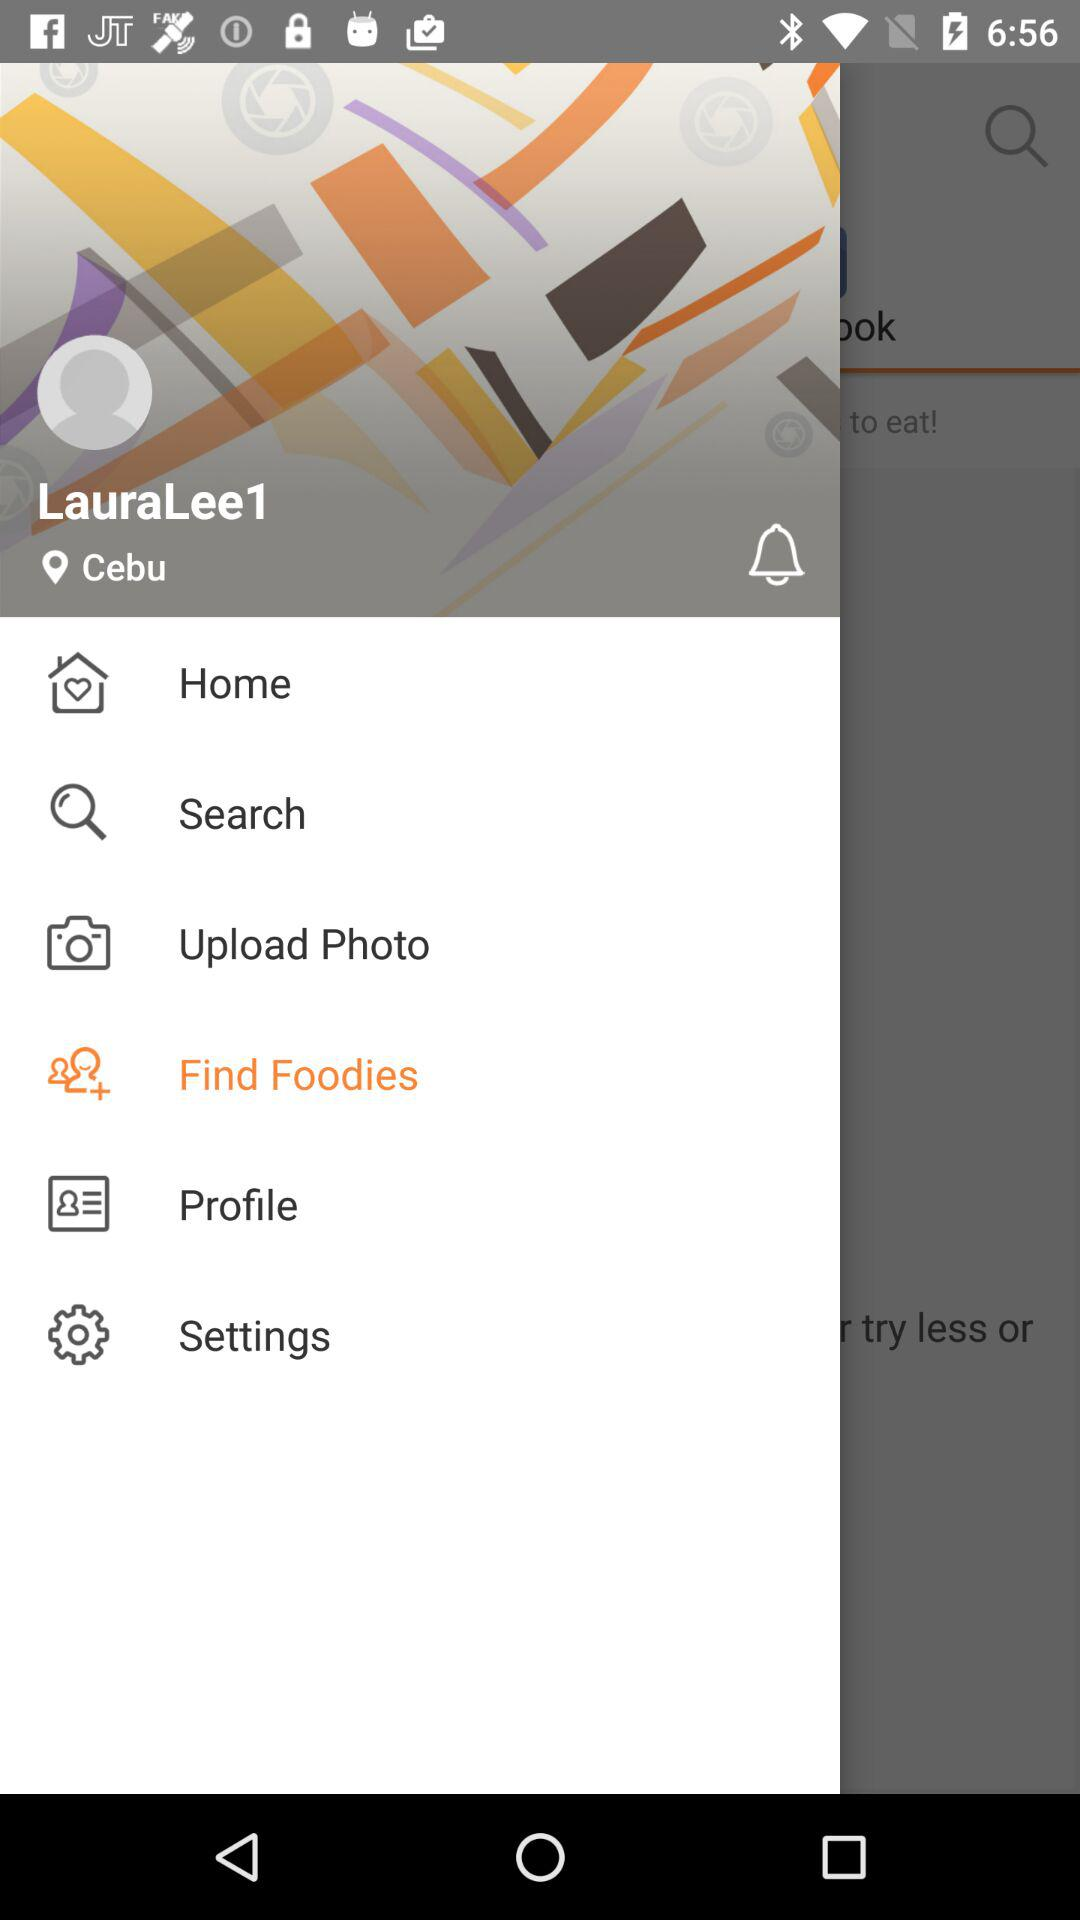Which item has been selected? The selected item is "Find Foodies". 